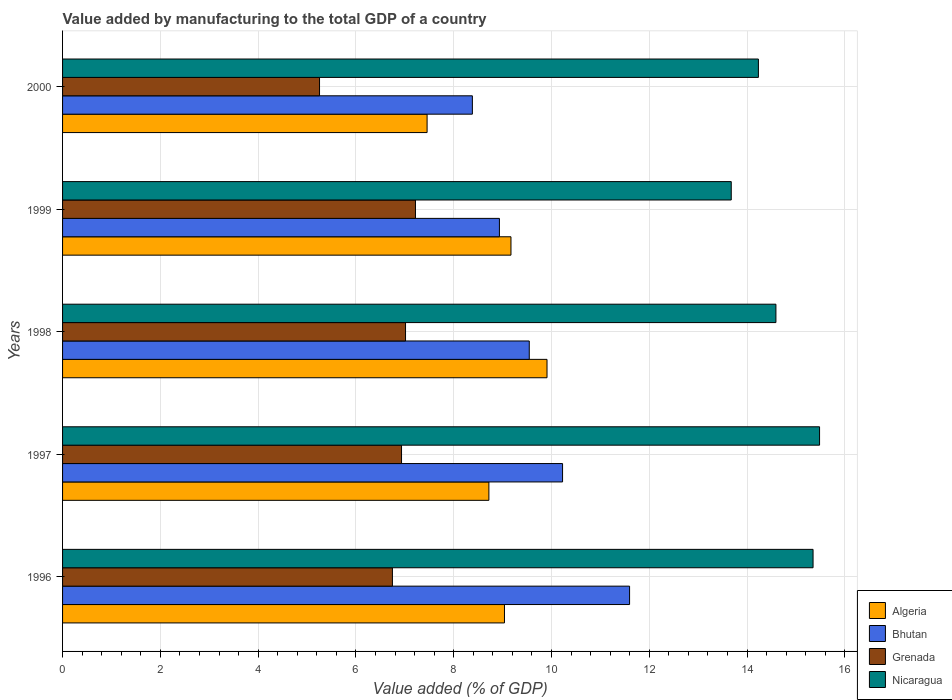How many different coloured bars are there?
Provide a succinct answer. 4. How many groups of bars are there?
Ensure brevity in your answer.  5. Are the number of bars on each tick of the Y-axis equal?
Keep it short and to the point. Yes. How many bars are there on the 3rd tick from the top?
Keep it short and to the point. 4. What is the value added by manufacturing to the total GDP in Nicaragua in 1999?
Your answer should be compact. 13.68. Across all years, what is the maximum value added by manufacturing to the total GDP in Bhutan?
Make the answer very short. 11.6. Across all years, what is the minimum value added by manufacturing to the total GDP in Nicaragua?
Keep it short and to the point. 13.68. What is the total value added by manufacturing to the total GDP in Bhutan in the graph?
Make the answer very short. 48.69. What is the difference between the value added by manufacturing to the total GDP in Algeria in 1996 and that in 1997?
Give a very brief answer. 0.32. What is the difference between the value added by manufacturing to the total GDP in Bhutan in 2000 and the value added by manufacturing to the total GDP in Grenada in 1999?
Provide a succinct answer. 1.16. What is the average value added by manufacturing to the total GDP in Bhutan per year?
Your response must be concise. 9.74. In the year 1996, what is the difference between the value added by manufacturing to the total GDP in Nicaragua and value added by manufacturing to the total GDP in Grenada?
Provide a succinct answer. 8.6. In how many years, is the value added by manufacturing to the total GDP in Nicaragua greater than 12.4 %?
Your response must be concise. 5. What is the ratio of the value added by manufacturing to the total GDP in Grenada in 1997 to that in 1999?
Offer a terse response. 0.96. What is the difference between the highest and the second highest value added by manufacturing to the total GDP in Algeria?
Offer a terse response. 0.74. What is the difference between the highest and the lowest value added by manufacturing to the total GDP in Nicaragua?
Your answer should be compact. 1.81. In how many years, is the value added by manufacturing to the total GDP in Bhutan greater than the average value added by manufacturing to the total GDP in Bhutan taken over all years?
Your answer should be compact. 2. Is it the case that in every year, the sum of the value added by manufacturing to the total GDP in Algeria and value added by manufacturing to the total GDP in Grenada is greater than the sum of value added by manufacturing to the total GDP in Nicaragua and value added by manufacturing to the total GDP in Bhutan?
Make the answer very short. No. What does the 2nd bar from the top in 1998 represents?
Offer a very short reply. Grenada. What does the 3rd bar from the bottom in 1998 represents?
Offer a very short reply. Grenada. How many bars are there?
Provide a succinct answer. 20. Are all the bars in the graph horizontal?
Offer a terse response. Yes. How many years are there in the graph?
Provide a short and direct response. 5. Does the graph contain grids?
Offer a very short reply. Yes. Where does the legend appear in the graph?
Provide a short and direct response. Bottom right. How many legend labels are there?
Your response must be concise. 4. What is the title of the graph?
Offer a terse response. Value added by manufacturing to the total GDP of a country. Does "Japan" appear as one of the legend labels in the graph?
Provide a short and direct response. No. What is the label or title of the X-axis?
Make the answer very short. Value added (% of GDP). What is the Value added (% of GDP) in Algeria in 1996?
Give a very brief answer. 9.04. What is the Value added (% of GDP) of Bhutan in 1996?
Your answer should be compact. 11.6. What is the Value added (% of GDP) of Grenada in 1996?
Ensure brevity in your answer.  6.75. What is the Value added (% of GDP) of Nicaragua in 1996?
Your answer should be compact. 15.35. What is the Value added (% of GDP) of Algeria in 1997?
Your answer should be very brief. 8.72. What is the Value added (% of GDP) in Bhutan in 1997?
Your response must be concise. 10.23. What is the Value added (% of GDP) in Grenada in 1997?
Make the answer very short. 6.93. What is the Value added (% of GDP) of Nicaragua in 1997?
Offer a terse response. 15.48. What is the Value added (% of GDP) of Algeria in 1998?
Make the answer very short. 9.91. What is the Value added (% of GDP) in Bhutan in 1998?
Your answer should be very brief. 9.55. What is the Value added (% of GDP) in Grenada in 1998?
Offer a very short reply. 7.02. What is the Value added (% of GDP) in Nicaragua in 1998?
Ensure brevity in your answer.  14.59. What is the Value added (% of GDP) of Algeria in 1999?
Give a very brief answer. 9.17. What is the Value added (% of GDP) in Bhutan in 1999?
Your answer should be compact. 8.94. What is the Value added (% of GDP) of Grenada in 1999?
Give a very brief answer. 7.22. What is the Value added (% of GDP) in Nicaragua in 1999?
Offer a terse response. 13.68. What is the Value added (% of GDP) in Algeria in 2000?
Provide a short and direct response. 7.46. What is the Value added (% of GDP) in Bhutan in 2000?
Give a very brief answer. 8.38. What is the Value added (% of GDP) in Grenada in 2000?
Your answer should be very brief. 5.26. What is the Value added (% of GDP) of Nicaragua in 2000?
Offer a very short reply. 14.23. Across all years, what is the maximum Value added (% of GDP) of Algeria?
Ensure brevity in your answer.  9.91. Across all years, what is the maximum Value added (% of GDP) of Bhutan?
Offer a very short reply. 11.6. Across all years, what is the maximum Value added (% of GDP) in Grenada?
Ensure brevity in your answer.  7.22. Across all years, what is the maximum Value added (% of GDP) of Nicaragua?
Keep it short and to the point. 15.48. Across all years, what is the minimum Value added (% of GDP) of Algeria?
Your answer should be compact. 7.46. Across all years, what is the minimum Value added (% of GDP) of Bhutan?
Give a very brief answer. 8.38. Across all years, what is the minimum Value added (% of GDP) in Grenada?
Your response must be concise. 5.26. Across all years, what is the minimum Value added (% of GDP) of Nicaragua?
Offer a terse response. 13.68. What is the total Value added (% of GDP) in Algeria in the graph?
Ensure brevity in your answer.  44.3. What is the total Value added (% of GDP) in Bhutan in the graph?
Keep it short and to the point. 48.69. What is the total Value added (% of GDP) of Grenada in the graph?
Keep it short and to the point. 33.17. What is the total Value added (% of GDP) in Nicaragua in the graph?
Provide a succinct answer. 73.34. What is the difference between the Value added (% of GDP) of Algeria in 1996 and that in 1997?
Make the answer very short. 0.32. What is the difference between the Value added (% of GDP) in Bhutan in 1996 and that in 1997?
Ensure brevity in your answer.  1.37. What is the difference between the Value added (% of GDP) of Grenada in 1996 and that in 1997?
Offer a very short reply. -0.19. What is the difference between the Value added (% of GDP) of Nicaragua in 1996 and that in 1997?
Offer a terse response. -0.13. What is the difference between the Value added (% of GDP) in Algeria in 1996 and that in 1998?
Make the answer very short. -0.87. What is the difference between the Value added (% of GDP) in Bhutan in 1996 and that in 1998?
Give a very brief answer. 2.05. What is the difference between the Value added (% of GDP) of Grenada in 1996 and that in 1998?
Your answer should be compact. -0.27. What is the difference between the Value added (% of GDP) in Nicaragua in 1996 and that in 1998?
Provide a succinct answer. 0.76. What is the difference between the Value added (% of GDP) in Algeria in 1996 and that in 1999?
Offer a terse response. -0.13. What is the difference between the Value added (% of GDP) of Bhutan in 1996 and that in 1999?
Your answer should be very brief. 2.66. What is the difference between the Value added (% of GDP) of Grenada in 1996 and that in 1999?
Provide a succinct answer. -0.47. What is the difference between the Value added (% of GDP) of Nicaragua in 1996 and that in 1999?
Your answer should be very brief. 1.67. What is the difference between the Value added (% of GDP) in Algeria in 1996 and that in 2000?
Keep it short and to the point. 1.58. What is the difference between the Value added (% of GDP) in Bhutan in 1996 and that in 2000?
Keep it short and to the point. 3.22. What is the difference between the Value added (% of GDP) of Grenada in 1996 and that in 2000?
Provide a short and direct response. 1.49. What is the difference between the Value added (% of GDP) of Nicaragua in 1996 and that in 2000?
Your answer should be compact. 1.12. What is the difference between the Value added (% of GDP) of Algeria in 1997 and that in 1998?
Provide a succinct answer. -1.19. What is the difference between the Value added (% of GDP) of Bhutan in 1997 and that in 1998?
Your answer should be compact. 0.68. What is the difference between the Value added (% of GDP) of Grenada in 1997 and that in 1998?
Provide a short and direct response. -0.08. What is the difference between the Value added (% of GDP) of Nicaragua in 1997 and that in 1998?
Your response must be concise. 0.89. What is the difference between the Value added (% of GDP) of Algeria in 1997 and that in 1999?
Your answer should be compact. -0.45. What is the difference between the Value added (% of GDP) in Bhutan in 1997 and that in 1999?
Make the answer very short. 1.29. What is the difference between the Value added (% of GDP) of Grenada in 1997 and that in 1999?
Your response must be concise. -0.28. What is the difference between the Value added (% of GDP) in Nicaragua in 1997 and that in 1999?
Your answer should be very brief. 1.81. What is the difference between the Value added (% of GDP) of Algeria in 1997 and that in 2000?
Provide a succinct answer. 1.26. What is the difference between the Value added (% of GDP) in Bhutan in 1997 and that in 2000?
Give a very brief answer. 1.84. What is the difference between the Value added (% of GDP) in Grenada in 1997 and that in 2000?
Provide a short and direct response. 1.68. What is the difference between the Value added (% of GDP) in Nicaragua in 1997 and that in 2000?
Offer a very short reply. 1.25. What is the difference between the Value added (% of GDP) in Algeria in 1998 and that in 1999?
Offer a terse response. 0.74. What is the difference between the Value added (% of GDP) in Bhutan in 1998 and that in 1999?
Make the answer very short. 0.61. What is the difference between the Value added (% of GDP) in Grenada in 1998 and that in 1999?
Give a very brief answer. -0.2. What is the difference between the Value added (% of GDP) of Nicaragua in 1998 and that in 1999?
Offer a very short reply. 0.91. What is the difference between the Value added (% of GDP) in Algeria in 1998 and that in 2000?
Provide a succinct answer. 2.45. What is the difference between the Value added (% of GDP) in Bhutan in 1998 and that in 2000?
Offer a terse response. 1.16. What is the difference between the Value added (% of GDP) in Grenada in 1998 and that in 2000?
Provide a succinct answer. 1.76. What is the difference between the Value added (% of GDP) in Nicaragua in 1998 and that in 2000?
Offer a very short reply. 0.36. What is the difference between the Value added (% of GDP) of Algeria in 1999 and that in 2000?
Provide a succinct answer. 1.72. What is the difference between the Value added (% of GDP) of Bhutan in 1999 and that in 2000?
Make the answer very short. 0.55. What is the difference between the Value added (% of GDP) of Grenada in 1999 and that in 2000?
Keep it short and to the point. 1.96. What is the difference between the Value added (% of GDP) of Nicaragua in 1999 and that in 2000?
Keep it short and to the point. -0.56. What is the difference between the Value added (% of GDP) of Algeria in 1996 and the Value added (% of GDP) of Bhutan in 1997?
Make the answer very short. -1.19. What is the difference between the Value added (% of GDP) of Algeria in 1996 and the Value added (% of GDP) of Grenada in 1997?
Your answer should be very brief. 2.11. What is the difference between the Value added (% of GDP) of Algeria in 1996 and the Value added (% of GDP) of Nicaragua in 1997?
Your answer should be very brief. -6.45. What is the difference between the Value added (% of GDP) in Bhutan in 1996 and the Value added (% of GDP) in Grenada in 1997?
Keep it short and to the point. 4.66. What is the difference between the Value added (% of GDP) in Bhutan in 1996 and the Value added (% of GDP) in Nicaragua in 1997?
Offer a very short reply. -3.89. What is the difference between the Value added (% of GDP) in Grenada in 1996 and the Value added (% of GDP) in Nicaragua in 1997?
Offer a terse response. -8.74. What is the difference between the Value added (% of GDP) in Algeria in 1996 and the Value added (% of GDP) in Bhutan in 1998?
Give a very brief answer. -0.51. What is the difference between the Value added (% of GDP) in Algeria in 1996 and the Value added (% of GDP) in Grenada in 1998?
Your response must be concise. 2.02. What is the difference between the Value added (% of GDP) of Algeria in 1996 and the Value added (% of GDP) of Nicaragua in 1998?
Make the answer very short. -5.55. What is the difference between the Value added (% of GDP) of Bhutan in 1996 and the Value added (% of GDP) of Grenada in 1998?
Your answer should be compact. 4.58. What is the difference between the Value added (% of GDP) in Bhutan in 1996 and the Value added (% of GDP) in Nicaragua in 1998?
Offer a very short reply. -2.99. What is the difference between the Value added (% of GDP) of Grenada in 1996 and the Value added (% of GDP) of Nicaragua in 1998?
Make the answer very short. -7.84. What is the difference between the Value added (% of GDP) in Algeria in 1996 and the Value added (% of GDP) in Bhutan in 1999?
Provide a succinct answer. 0.1. What is the difference between the Value added (% of GDP) in Algeria in 1996 and the Value added (% of GDP) in Grenada in 1999?
Your answer should be compact. 1.82. What is the difference between the Value added (% of GDP) of Algeria in 1996 and the Value added (% of GDP) of Nicaragua in 1999?
Your answer should be compact. -4.64. What is the difference between the Value added (% of GDP) in Bhutan in 1996 and the Value added (% of GDP) in Grenada in 1999?
Your answer should be very brief. 4.38. What is the difference between the Value added (% of GDP) in Bhutan in 1996 and the Value added (% of GDP) in Nicaragua in 1999?
Your answer should be very brief. -2.08. What is the difference between the Value added (% of GDP) in Grenada in 1996 and the Value added (% of GDP) in Nicaragua in 1999?
Make the answer very short. -6.93. What is the difference between the Value added (% of GDP) in Algeria in 1996 and the Value added (% of GDP) in Bhutan in 2000?
Provide a short and direct response. 0.66. What is the difference between the Value added (% of GDP) of Algeria in 1996 and the Value added (% of GDP) of Grenada in 2000?
Your answer should be compact. 3.78. What is the difference between the Value added (% of GDP) of Algeria in 1996 and the Value added (% of GDP) of Nicaragua in 2000?
Your answer should be compact. -5.19. What is the difference between the Value added (% of GDP) in Bhutan in 1996 and the Value added (% of GDP) in Grenada in 2000?
Your response must be concise. 6.34. What is the difference between the Value added (% of GDP) in Bhutan in 1996 and the Value added (% of GDP) in Nicaragua in 2000?
Give a very brief answer. -2.64. What is the difference between the Value added (% of GDP) in Grenada in 1996 and the Value added (% of GDP) in Nicaragua in 2000?
Keep it short and to the point. -7.49. What is the difference between the Value added (% of GDP) in Algeria in 1997 and the Value added (% of GDP) in Bhutan in 1998?
Your answer should be very brief. -0.83. What is the difference between the Value added (% of GDP) of Algeria in 1997 and the Value added (% of GDP) of Grenada in 1998?
Offer a terse response. 1.71. What is the difference between the Value added (% of GDP) in Algeria in 1997 and the Value added (% of GDP) in Nicaragua in 1998?
Your answer should be very brief. -5.87. What is the difference between the Value added (% of GDP) of Bhutan in 1997 and the Value added (% of GDP) of Grenada in 1998?
Your answer should be compact. 3.21. What is the difference between the Value added (% of GDP) in Bhutan in 1997 and the Value added (% of GDP) in Nicaragua in 1998?
Your answer should be very brief. -4.36. What is the difference between the Value added (% of GDP) in Grenada in 1997 and the Value added (% of GDP) in Nicaragua in 1998?
Your answer should be very brief. -7.66. What is the difference between the Value added (% of GDP) of Algeria in 1997 and the Value added (% of GDP) of Bhutan in 1999?
Provide a short and direct response. -0.22. What is the difference between the Value added (% of GDP) of Algeria in 1997 and the Value added (% of GDP) of Grenada in 1999?
Ensure brevity in your answer.  1.5. What is the difference between the Value added (% of GDP) in Algeria in 1997 and the Value added (% of GDP) in Nicaragua in 1999?
Provide a succinct answer. -4.96. What is the difference between the Value added (% of GDP) in Bhutan in 1997 and the Value added (% of GDP) in Grenada in 1999?
Offer a terse response. 3.01. What is the difference between the Value added (% of GDP) of Bhutan in 1997 and the Value added (% of GDP) of Nicaragua in 1999?
Provide a succinct answer. -3.45. What is the difference between the Value added (% of GDP) in Grenada in 1997 and the Value added (% of GDP) in Nicaragua in 1999?
Your answer should be compact. -6.74. What is the difference between the Value added (% of GDP) in Algeria in 1997 and the Value added (% of GDP) in Bhutan in 2000?
Make the answer very short. 0.34. What is the difference between the Value added (% of GDP) of Algeria in 1997 and the Value added (% of GDP) of Grenada in 2000?
Give a very brief answer. 3.46. What is the difference between the Value added (% of GDP) in Algeria in 1997 and the Value added (% of GDP) in Nicaragua in 2000?
Provide a succinct answer. -5.51. What is the difference between the Value added (% of GDP) in Bhutan in 1997 and the Value added (% of GDP) in Grenada in 2000?
Give a very brief answer. 4.97. What is the difference between the Value added (% of GDP) in Bhutan in 1997 and the Value added (% of GDP) in Nicaragua in 2000?
Keep it short and to the point. -4.01. What is the difference between the Value added (% of GDP) of Grenada in 1997 and the Value added (% of GDP) of Nicaragua in 2000?
Keep it short and to the point. -7.3. What is the difference between the Value added (% of GDP) of Algeria in 1998 and the Value added (% of GDP) of Bhutan in 1999?
Provide a succinct answer. 0.97. What is the difference between the Value added (% of GDP) in Algeria in 1998 and the Value added (% of GDP) in Grenada in 1999?
Provide a succinct answer. 2.69. What is the difference between the Value added (% of GDP) in Algeria in 1998 and the Value added (% of GDP) in Nicaragua in 1999?
Your response must be concise. -3.77. What is the difference between the Value added (% of GDP) of Bhutan in 1998 and the Value added (% of GDP) of Grenada in 1999?
Offer a terse response. 2.33. What is the difference between the Value added (% of GDP) of Bhutan in 1998 and the Value added (% of GDP) of Nicaragua in 1999?
Provide a succinct answer. -4.13. What is the difference between the Value added (% of GDP) of Grenada in 1998 and the Value added (% of GDP) of Nicaragua in 1999?
Your answer should be compact. -6.66. What is the difference between the Value added (% of GDP) of Algeria in 1998 and the Value added (% of GDP) of Bhutan in 2000?
Offer a very short reply. 1.53. What is the difference between the Value added (% of GDP) of Algeria in 1998 and the Value added (% of GDP) of Grenada in 2000?
Offer a terse response. 4.65. What is the difference between the Value added (% of GDP) in Algeria in 1998 and the Value added (% of GDP) in Nicaragua in 2000?
Offer a very short reply. -4.32. What is the difference between the Value added (% of GDP) of Bhutan in 1998 and the Value added (% of GDP) of Grenada in 2000?
Provide a succinct answer. 4.29. What is the difference between the Value added (% of GDP) in Bhutan in 1998 and the Value added (% of GDP) in Nicaragua in 2000?
Give a very brief answer. -4.69. What is the difference between the Value added (% of GDP) of Grenada in 1998 and the Value added (% of GDP) of Nicaragua in 2000?
Your answer should be compact. -7.22. What is the difference between the Value added (% of GDP) of Algeria in 1999 and the Value added (% of GDP) of Bhutan in 2000?
Offer a very short reply. 0.79. What is the difference between the Value added (% of GDP) of Algeria in 1999 and the Value added (% of GDP) of Grenada in 2000?
Your response must be concise. 3.92. What is the difference between the Value added (% of GDP) in Algeria in 1999 and the Value added (% of GDP) in Nicaragua in 2000?
Ensure brevity in your answer.  -5.06. What is the difference between the Value added (% of GDP) in Bhutan in 1999 and the Value added (% of GDP) in Grenada in 2000?
Give a very brief answer. 3.68. What is the difference between the Value added (% of GDP) of Bhutan in 1999 and the Value added (% of GDP) of Nicaragua in 2000?
Your answer should be compact. -5.3. What is the difference between the Value added (% of GDP) of Grenada in 1999 and the Value added (% of GDP) of Nicaragua in 2000?
Give a very brief answer. -7.01. What is the average Value added (% of GDP) of Algeria per year?
Keep it short and to the point. 8.86. What is the average Value added (% of GDP) of Bhutan per year?
Your answer should be compact. 9.74. What is the average Value added (% of GDP) in Grenada per year?
Your answer should be compact. 6.63. What is the average Value added (% of GDP) of Nicaragua per year?
Offer a very short reply. 14.67. In the year 1996, what is the difference between the Value added (% of GDP) in Algeria and Value added (% of GDP) in Bhutan?
Give a very brief answer. -2.56. In the year 1996, what is the difference between the Value added (% of GDP) in Algeria and Value added (% of GDP) in Grenada?
Ensure brevity in your answer.  2.29. In the year 1996, what is the difference between the Value added (% of GDP) of Algeria and Value added (% of GDP) of Nicaragua?
Offer a terse response. -6.31. In the year 1996, what is the difference between the Value added (% of GDP) of Bhutan and Value added (% of GDP) of Grenada?
Keep it short and to the point. 4.85. In the year 1996, what is the difference between the Value added (% of GDP) of Bhutan and Value added (% of GDP) of Nicaragua?
Your answer should be very brief. -3.75. In the year 1996, what is the difference between the Value added (% of GDP) in Grenada and Value added (% of GDP) in Nicaragua?
Your answer should be compact. -8.6. In the year 1997, what is the difference between the Value added (% of GDP) in Algeria and Value added (% of GDP) in Bhutan?
Your answer should be compact. -1.51. In the year 1997, what is the difference between the Value added (% of GDP) of Algeria and Value added (% of GDP) of Grenada?
Give a very brief answer. 1.79. In the year 1997, what is the difference between the Value added (% of GDP) in Algeria and Value added (% of GDP) in Nicaragua?
Your response must be concise. -6.76. In the year 1997, what is the difference between the Value added (% of GDP) of Bhutan and Value added (% of GDP) of Grenada?
Your answer should be compact. 3.29. In the year 1997, what is the difference between the Value added (% of GDP) in Bhutan and Value added (% of GDP) in Nicaragua?
Your answer should be compact. -5.26. In the year 1997, what is the difference between the Value added (% of GDP) of Grenada and Value added (% of GDP) of Nicaragua?
Offer a terse response. -8.55. In the year 1998, what is the difference between the Value added (% of GDP) of Algeria and Value added (% of GDP) of Bhutan?
Offer a very short reply. 0.36. In the year 1998, what is the difference between the Value added (% of GDP) of Algeria and Value added (% of GDP) of Grenada?
Your answer should be compact. 2.89. In the year 1998, what is the difference between the Value added (% of GDP) of Algeria and Value added (% of GDP) of Nicaragua?
Offer a very short reply. -4.68. In the year 1998, what is the difference between the Value added (% of GDP) in Bhutan and Value added (% of GDP) in Grenada?
Offer a very short reply. 2.53. In the year 1998, what is the difference between the Value added (% of GDP) of Bhutan and Value added (% of GDP) of Nicaragua?
Give a very brief answer. -5.05. In the year 1998, what is the difference between the Value added (% of GDP) of Grenada and Value added (% of GDP) of Nicaragua?
Provide a short and direct response. -7.58. In the year 1999, what is the difference between the Value added (% of GDP) in Algeria and Value added (% of GDP) in Bhutan?
Offer a very short reply. 0.24. In the year 1999, what is the difference between the Value added (% of GDP) in Algeria and Value added (% of GDP) in Grenada?
Give a very brief answer. 1.95. In the year 1999, what is the difference between the Value added (% of GDP) in Algeria and Value added (% of GDP) in Nicaragua?
Your answer should be compact. -4.51. In the year 1999, what is the difference between the Value added (% of GDP) of Bhutan and Value added (% of GDP) of Grenada?
Provide a short and direct response. 1.72. In the year 1999, what is the difference between the Value added (% of GDP) in Bhutan and Value added (% of GDP) in Nicaragua?
Your response must be concise. -4.74. In the year 1999, what is the difference between the Value added (% of GDP) in Grenada and Value added (% of GDP) in Nicaragua?
Keep it short and to the point. -6.46. In the year 2000, what is the difference between the Value added (% of GDP) of Algeria and Value added (% of GDP) of Bhutan?
Make the answer very short. -0.93. In the year 2000, what is the difference between the Value added (% of GDP) of Algeria and Value added (% of GDP) of Grenada?
Make the answer very short. 2.2. In the year 2000, what is the difference between the Value added (% of GDP) of Algeria and Value added (% of GDP) of Nicaragua?
Provide a short and direct response. -6.78. In the year 2000, what is the difference between the Value added (% of GDP) of Bhutan and Value added (% of GDP) of Grenada?
Provide a succinct answer. 3.13. In the year 2000, what is the difference between the Value added (% of GDP) of Bhutan and Value added (% of GDP) of Nicaragua?
Ensure brevity in your answer.  -5.85. In the year 2000, what is the difference between the Value added (% of GDP) of Grenada and Value added (% of GDP) of Nicaragua?
Your answer should be very brief. -8.98. What is the ratio of the Value added (% of GDP) in Algeria in 1996 to that in 1997?
Offer a very short reply. 1.04. What is the ratio of the Value added (% of GDP) of Bhutan in 1996 to that in 1997?
Offer a terse response. 1.13. What is the ratio of the Value added (% of GDP) in Grenada in 1996 to that in 1997?
Your answer should be compact. 0.97. What is the ratio of the Value added (% of GDP) of Nicaragua in 1996 to that in 1997?
Your response must be concise. 0.99. What is the ratio of the Value added (% of GDP) of Algeria in 1996 to that in 1998?
Your response must be concise. 0.91. What is the ratio of the Value added (% of GDP) of Bhutan in 1996 to that in 1998?
Keep it short and to the point. 1.21. What is the ratio of the Value added (% of GDP) in Grenada in 1996 to that in 1998?
Provide a short and direct response. 0.96. What is the ratio of the Value added (% of GDP) in Nicaragua in 1996 to that in 1998?
Your answer should be compact. 1.05. What is the ratio of the Value added (% of GDP) in Algeria in 1996 to that in 1999?
Ensure brevity in your answer.  0.99. What is the ratio of the Value added (% of GDP) of Bhutan in 1996 to that in 1999?
Provide a succinct answer. 1.3. What is the ratio of the Value added (% of GDP) of Grenada in 1996 to that in 1999?
Provide a short and direct response. 0.93. What is the ratio of the Value added (% of GDP) of Nicaragua in 1996 to that in 1999?
Provide a succinct answer. 1.12. What is the ratio of the Value added (% of GDP) in Algeria in 1996 to that in 2000?
Provide a succinct answer. 1.21. What is the ratio of the Value added (% of GDP) in Bhutan in 1996 to that in 2000?
Ensure brevity in your answer.  1.38. What is the ratio of the Value added (% of GDP) of Grenada in 1996 to that in 2000?
Your response must be concise. 1.28. What is the ratio of the Value added (% of GDP) in Nicaragua in 1996 to that in 2000?
Ensure brevity in your answer.  1.08. What is the ratio of the Value added (% of GDP) in Bhutan in 1997 to that in 1998?
Your response must be concise. 1.07. What is the ratio of the Value added (% of GDP) in Grenada in 1997 to that in 1998?
Your answer should be compact. 0.99. What is the ratio of the Value added (% of GDP) of Nicaragua in 1997 to that in 1998?
Provide a succinct answer. 1.06. What is the ratio of the Value added (% of GDP) of Algeria in 1997 to that in 1999?
Your answer should be compact. 0.95. What is the ratio of the Value added (% of GDP) in Bhutan in 1997 to that in 1999?
Keep it short and to the point. 1.14. What is the ratio of the Value added (% of GDP) of Grenada in 1997 to that in 1999?
Offer a terse response. 0.96. What is the ratio of the Value added (% of GDP) in Nicaragua in 1997 to that in 1999?
Provide a succinct answer. 1.13. What is the ratio of the Value added (% of GDP) of Algeria in 1997 to that in 2000?
Make the answer very short. 1.17. What is the ratio of the Value added (% of GDP) of Bhutan in 1997 to that in 2000?
Ensure brevity in your answer.  1.22. What is the ratio of the Value added (% of GDP) of Grenada in 1997 to that in 2000?
Make the answer very short. 1.32. What is the ratio of the Value added (% of GDP) in Nicaragua in 1997 to that in 2000?
Your response must be concise. 1.09. What is the ratio of the Value added (% of GDP) in Algeria in 1998 to that in 1999?
Ensure brevity in your answer.  1.08. What is the ratio of the Value added (% of GDP) of Bhutan in 1998 to that in 1999?
Your answer should be very brief. 1.07. What is the ratio of the Value added (% of GDP) of Grenada in 1998 to that in 1999?
Offer a terse response. 0.97. What is the ratio of the Value added (% of GDP) in Nicaragua in 1998 to that in 1999?
Give a very brief answer. 1.07. What is the ratio of the Value added (% of GDP) in Algeria in 1998 to that in 2000?
Keep it short and to the point. 1.33. What is the ratio of the Value added (% of GDP) in Bhutan in 1998 to that in 2000?
Your answer should be compact. 1.14. What is the ratio of the Value added (% of GDP) of Grenada in 1998 to that in 2000?
Your answer should be very brief. 1.33. What is the ratio of the Value added (% of GDP) in Nicaragua in 1998 to that in 2000?
Provide a short and direct response. 1.03. What is the ratio of the Value added (% of GDP) in Algeria in 1999 to that in 2000?
Provide a succinct answer. 1.23. What is the ratio of the Value added (% of GDP) in Bhutan in 1999 to that in 2000?
Offer a very short reply. 1.07. What is the ratio of the Value added (% of GDP) of Grenada in 1999 to that in 2000?
Keep it short and to the point. 1.37. What is the ratio of the Value added (% of GDP) in Nicaragua in 1999 to that in 2000?
Keep it short and to the point. 0.96. What is the difference between the highest and the second highest Value added (% of GDP) in Algeria?
Your answer should be compact. 0.74. What is the difference between the highest and the second highest Value added (% of GDP) of Bhutan?
Your answer should be very brief. 1.37. What is the difference between the highest and the second highest Value added (% of GDP) of Grenada?
Provide a short and direct response. 0.2. What is the difference between the highest and the second highest Value added (% of GDP) of Nicaragua?
Make the answer very short. 0.13. What is the difference between the highest and the lowest Value added (% of GDP) in Algeria?
Your answer should be very brief. 2.45. What is the difference between the highest and the lowest Value added (% of GDP) of Bhutan?
Provide a short and direct response. 3.22. What is the difference between the highest and the lowest Value added (% of GDP) in Grenada?
Offer a terse response. 1.96. What is the difference between the highest and the lowest Value added (% of GDP) in Nicaragua?
Make the answer very short. 1.81. 